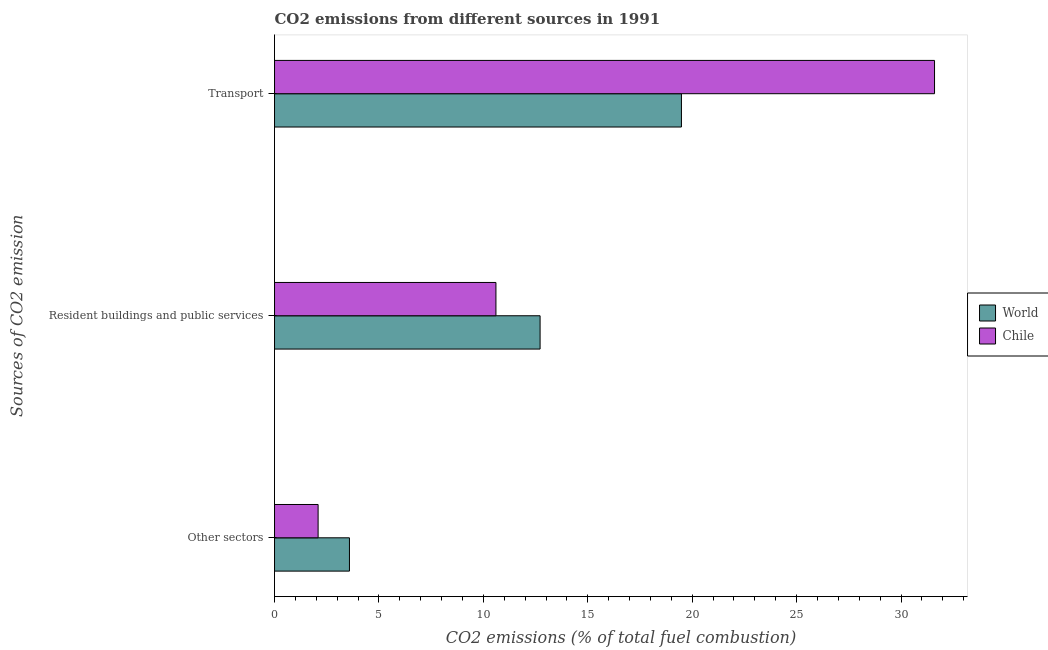How many different coloured bars are there?
Provide a short and direct response. 2. How many groups of bars are there?
Provide a short and direct response. 3. What is the label of the 1st group of bars from the top?
Make the answer very short. Transport. What is the percentage of co2 emissions from other sectors in World?
Your answer should be very brief. 3.59. Across all countries, what is the maximum percentage of co2 emissions from transport?
Ensure brevity in your answer.  31.61. Across all countries, what is the minimum percentage of co2 emissions from resident buildings and public services?
Provide a succinct answer. 10.6. In which country was the percentage of co2 emissions from resident buildings and public services maximum?
Give a very brief answer. World. What is the total percentage of co2 emissions from resident buildings and public services in the graph?
Provide a succinct answer. 23.32. What is the difference between the percentage of co2 emissions from transport in World and that in Chile?
Your answer should be very brief. -12.12. What is the difference between the percentage of co2 emissions from transport in Chile and the percentage of co2 emissions from resident buildings and public services in World?
Your answer should be very brief. 18.89. What is the average percentage of co2 emissions from transport per country?
Provide a short and direct response. 25.55. What is the difference between the percentage of co2 emissions from other sectors and percentage of co2 emissions from transport in Chile?
Ensure brevity in your answer.  -29.52. In how many countries, is the percentage of co2 emissions from other sectors greater than 12 %?
Offer a terse response. 0. What is the ratio of the percentage of co2 emissions from resident buildings and public services in World to that in Chile?
Make the answer very short. 1.2. Is the percentage of co2 emissions from resident buildings and public services in World less than that in Chile?
Give a very brief answer. No. What is the difference between the highest and the second highest percentage of co2 emissions from resident buildings and public services?
Provide a succinct answer. 2.11. What is the difference between the highest and the lowest percentage of co2 emissions from resident buildings and public services?
Your answer should be compact. 2.11. What does the 1st bar from the top in Other sectors represents?
Your answer should be very brief. Chile. How many countries are there in the graph?
Offer a very short reply. 2. What is the difference between two consecutive major ticks on the X-axis?
Offer a very short reply. 5. Does the graph contain grids?
Your response must be concise. No. How are the legend labels stacked?
Your response must be concise. Vertical. What is the title of the graph?
Offer a very short reply. CO2 emissions from different sources in 1991. Does "Togo" appear as one of the legend labels in the graph?
Offer a very short reply. No. What is the label or title of the X-axis?
Offer a terse response. CO2 emissions (% of total fuel combustion). What is the label or title of the Y-axis?
Your answer should be very brief. Sources of CO2 emission. What is the CO2 emissions (% of total fuel combustion) of World in Other sectors?
Provide a succinct answer. 3.59. What is the CO2 emissions (% of total fuel combustion) of Chile in Other sectors?
Your response must be concise. 2.09. What is the CO2 emissions (% of total fuel combustion) in World in Resident buildings and public services?
Provide a succinct answer. 12.72. What is the CO2 emissions (% of total fuel combustion) of Chile in Resident buildings and public services?
Your answer should be compact. 10.6. What is the CO2 emissions (% of total fuel combustion) of World in Transport?
Provide a succinct answer. 19.49. What is the CO2 emissions (% of total fuel combustion) of Chile in Transport?
Keep it short and to the point. 31.61. Across all Sources of CO2 emission, what is the maximum CO2 emissions (% of total fuel combustion) of World?
Your answer should be very brief. 19.49. Across all Sources of CO2 emission, what is the maximum CO2 emissions (% of total fuel combustion) in Chile?
Make the answer very short. 31.61. Across all Sources of CO2 emission, what is the minimum CO2 emissions (% of total fuel combustion) in World?
Keep it short and to the point. 3.59. Across all Sources of CO2 emission, what is the minimum CO2 emissions (% of total fuel combustion) of Chile?
Offer a terse response. 2.09. What is the total CO2 emissions (% of total fuel combustion) in World in the graph?
Offer a very short reply. 35.79. What is the total CO2 emissions (% of total fuel combustion) of Chile in the graph?
Your response must be concise. 44.29. What is the difference between the CO2 emissions (% of total fuel combustion) in World in Other sectors and that in Resident buildings and public services?
Make the answer very short. -9.13. What is the difference between the CO2 emissions (% of total fuel combustion) in Chile in Other sectors and that in Resident buildings and public services?
Ensure brevity in your answer.  -8.52. What is the difference between the CO2 emissions (% of total fuel combustion) of World in Other sectors and that in Transport?
Keep it short and to the point. -15.9. What is the difference between the CO2 emissions (% of total fuel combustion) in Chile in Other sectors and that in Transport?
Offer a very short reply. -29.52. What is the difference between the CO2 emissions (% of total fuel combustion) in World in Resident buildings and public services and that in Transport?
Provide a succinct answer. -6.77. What is the difference between the CO2 emissions (% of total fuel combustion) in Chile in Resident buildings and public services and that in Transport?
Your answer should be very brief. -21. What is the difference between the CO2 emissions (% of total fuel combustion) in World in Other sectors and the CO2 emissions (% of total fuel combustion) in Chile in Resident buildings and public services?
Your answer should be compact. -7.01. What is the difference between the CO2 emissions (% of total fuel combustion) of World in Other sectors and the CO2 emissions (% of total fuel combustion) of Chile in Transport?
Provide a succinct answer. -28.02. What is the difference between the CO2 emissions (% of total fuel combustion) in World in Resident buildings and public services and the CO2 emissions (% of total fuel combustion) in Chile in Transport?
Keep it short and to the point. -18.89. What is the average CO2 emissions (% of total fuel combustion) in World per Sources of CO2 emission?
Give a very brief answer. 11.93. What is the average CO2 emissions (% of total fuel combustion) in Chile per Sources of CO2 emission?
Your answer should be very brief. 14.77. What is the difference between the CO2 emissions (% of total fuel combustion) in World and CO2 emissions (% of total fuel combustion) in Chile in Other sectors?
Give a very brief answer. 1.5. What is the difference between the CO2 emissions (% of total fuel combustion) in World and CO2 emissions (% of total fuel combustion) in Chile in Resident buildings and public services?
Offer a terse response. 2.11. What is the difference between the CO2 emissions (% of total fuel combustion) in World and CO2 emissions (% of total fuel combustion) in Chile in Transport?
Provide a short and direct response. -12.12. What is the ratio of the CO2 emissions (% of total fuel combustion) in World in Other sectors to that in Resident buildings and public services?
Ensure brevity in your answer.  0.28. What is the ratio of the CO2 emissions (% of total fuel combustion) in Chile in Other sectors to that in Resident buildings and public services?
Offer a terse response. 0.2. What is the ratio of the CO2 emissions (% of total fuel combustion) in World in Other sectors to that in Transport?
Provide a short and direct response. 0.18. What is the ratio of the CO2 emissions (% of total fuel combustion) of Chile in Other sectors to that in Transport?
Your answer should be very brief. 0.07. What is the ratio of the CO2 emissions (% of total fuel combustion) of World in Resident buildings and public services to that in Transport?
Provide a succinct answer. 0.65. What is the ratio of the CO2 emissions (% of total fuel combustion) of Chile in Resident buildings and public services to that in Transport?
Offer a very short reply. 0.34. What is the difference between the highest and the second highest CO2 emissions (% of total fuel combustion) in World?
Provide a succinct answer. 6.77. What is the difference between the highest and the second highest CO2 emissions (% of total fuel combustion) in Chile?
Your answer should be compact. 21. What is the difference between the highest and the lowest CO2 emissions (% of total fuel combustion) of World?
Offer a terse response. 15.9. What is the difference between the highest and the lowest CO2 emissions (% of total fuel combustion) in Chile?
Your answer should be very brief. 29.52. 